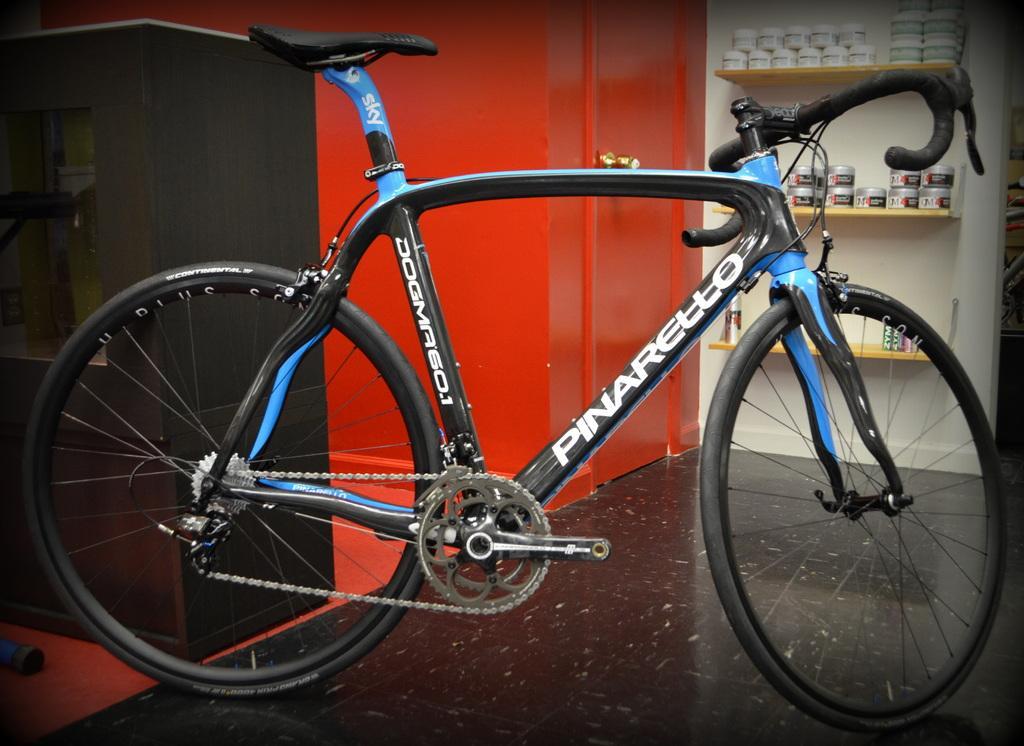Please provide a concise description of this image. In this image, we can see a bicycle on the floor, we can see a red door, there are some shelves, we can see some objects kept on the shelves. 